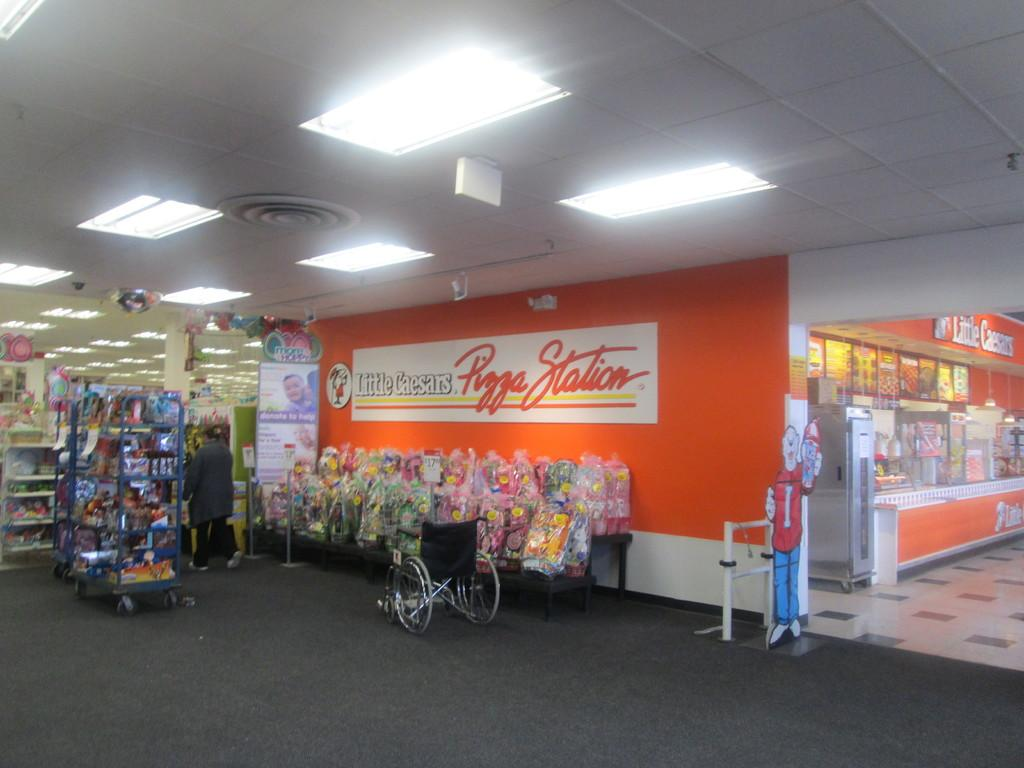<image>
Create a compact narrative representing the image presented. The Little Caesars Pizza Station appears to be deserted at this time. 